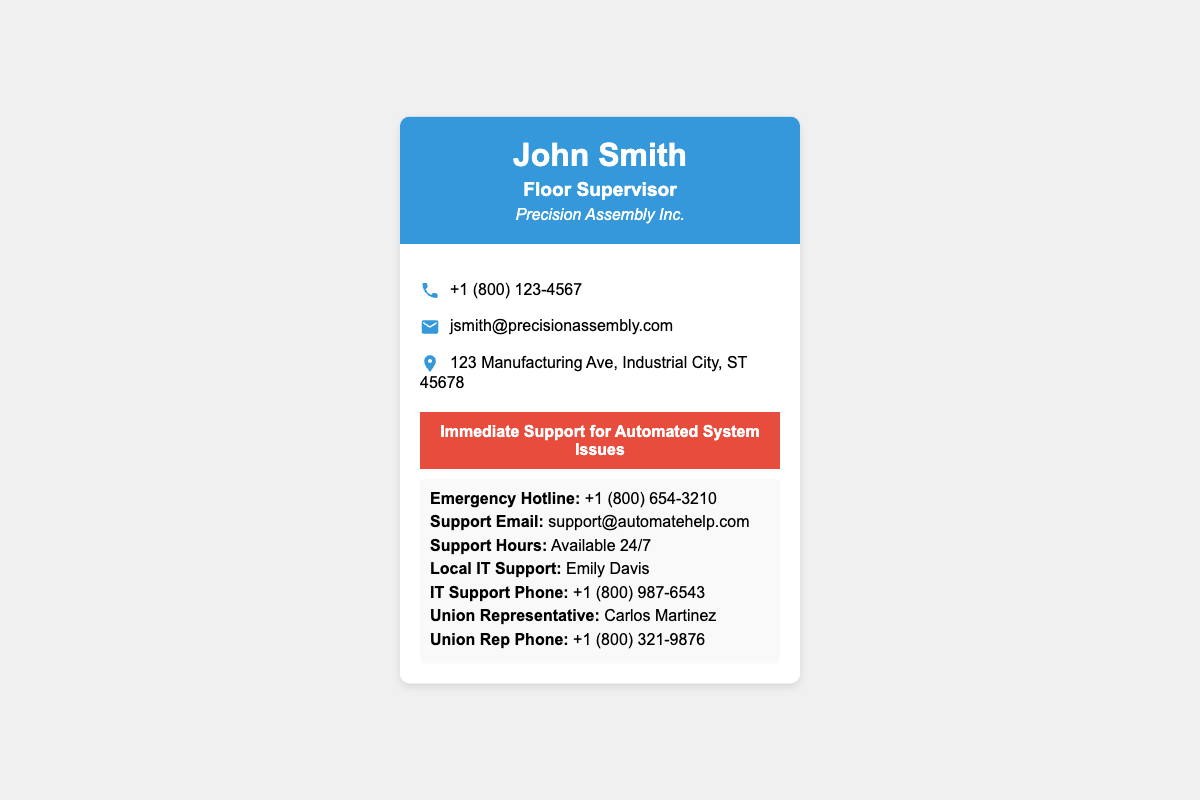What is the name of the floor supervisor? The name is displayed prominently at the top of the card, which is John Smith.
Answer: John Smith Which company does John Smith work for? The company name is listed in italics under the title, identifying it as Precision Assembly Inc.
Answer: Precision Assembly Inc What is the emergency hotline number? The emergency hotline is specifically stated under the support information section.
Answer: +1 (800) 654-3210 What is the support email address? The email address for support is indicated clearly in the support content section.
Answer: support@automatehelp.com Who is the local IT support contact? The local IT support representative's name is provided in the support content section.
Answer: Emily Davis What are the support hours mentioned? The document states that support is available around the clock for assistance.
Answer: Available 24/7 Which union representative is listed? The union representative's name is included in the support information section of the card.
Answer: Carlos Martinez What is the phone number for the IT support? The IT support phone number is specified clearly in the support section.
Answer: +1 (800) 987-6543 What is the address provided on the card? The address is mentioned towards the bottom of the contact information section.
Answer: 123 Manufacturing Ave, Industrial City, ST 45678 